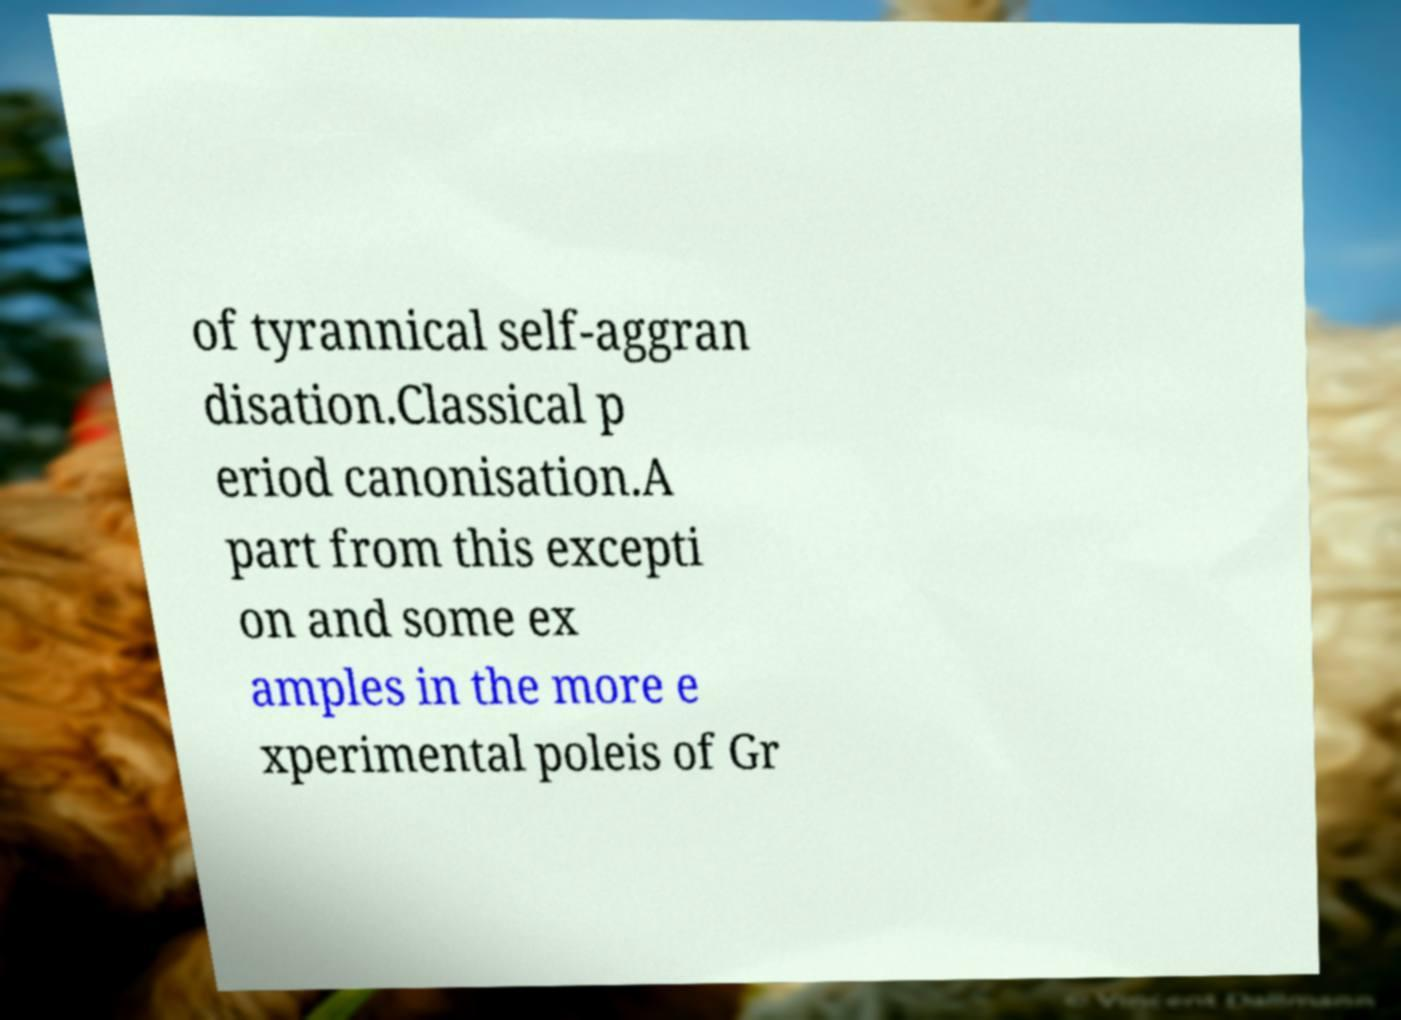What messages or text are displayed in this image? I need them in a readable, typed format. of tyrannical self-aggran disation.Classical p eriod canonisation.A part from this excepti on and some ex amples in the more e xperimental poleis of Gr 